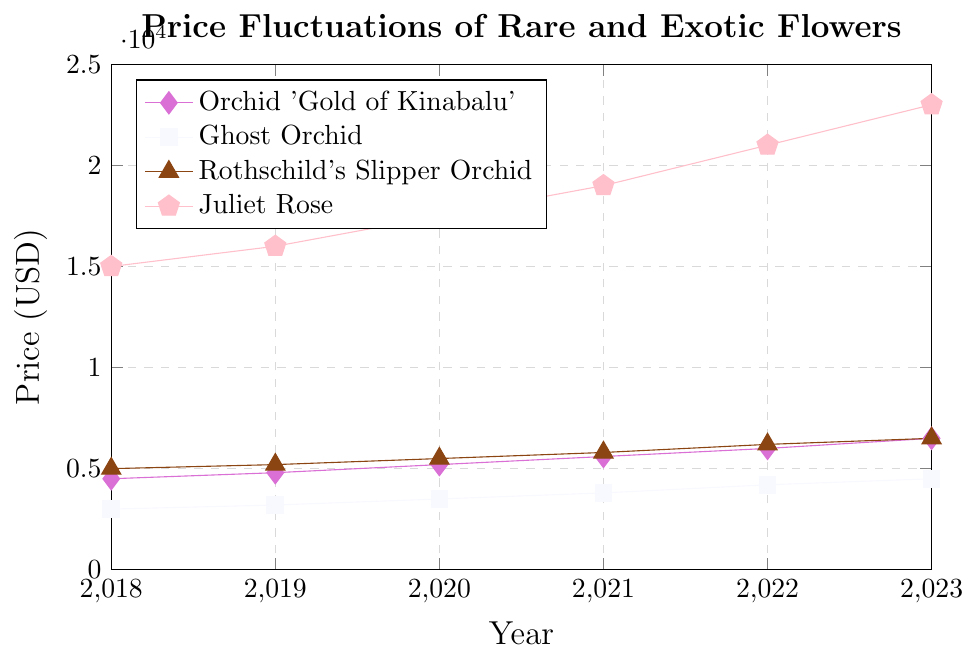Which flower saw the highest price increase over the period from 2018 to 2023? Calculate the difference in price for each flower from 2018 to 2023: Orchid 'Gold of Kinabalu' (6500 - 4500 = 2000), Ghost Orchid (4500 - 3000 = 1500), Rothschild's Slipper Orchid (6500 - 5000 = 1500), Juliet Rose (23000 - 15000 = 8000). Comparing these values, Juliet Rose has the highest increase of 8000.
Answer: Juliet Rose How much more expensive was Juliet Rose compared to Orchid 'Gold of Kinabalu' in 2021? Find the prices in 2021 for Juliet Rose and Orchid 'Gold of Kinabalu': Juliet Rose (19000), Orchid 'Gold of Kinabalu' (5600). Subtract the price of Orchid 'Gold of Kinabalu' from Juliet Rose (19000 - 5600 = 13400).
Answer: 13400 In which year did the price of the Ghost Orchid surpass 4000 USD? Identify the first year where Ghost Orchid's price was greater than 4000: In 2022, the price of Ghost Orchid is 4200, which is the first instance it surpasses 4000.
Answer: 2022 Which flower maintained the most consistent price increase each year? Calculate the yearly increase for each flower: Orchid 'Gold of Kinabalu' (300, 400, 400, 400, 500), Ghost Orchid (200, 300, 300, 400, 300), Rothschild's Slipper Orchid (200, 300, 300, 400, 300), Juliet Rose (1000, 1500, 1500, 2000). Orchid 'Gold of Kinabalu' increased by 400 for most years, making it the most consistent.
Answer: Orchid 'Gold of Kinabalu' What is the average price of Rothschild's Slipper Orchid over the 5 years? Sum the prices from 2018 to 2023: (5000 + 5200 + 5500 + 5800 + 6200 + 6500 = 34200). Divide by the number of years (34200 / 6 = 5700).
Answer: 5700 Did any flower's price decrease at any point over the 5 years? Inspect the trend for each flower over the years. All flowers show a continuous increase in price with no decrease from 2018 to 2023.
Answer: No By how much did Orchid 'Gold of Kinabalu' cost more than Ghost Orchid in 2020? Look at their prices in 2020: Orchid 'Gold of Kinabalu' (5200), Ghost Orchid (3500). Find the difference (5200 - 3500 = 1700).
Answer: 1700 